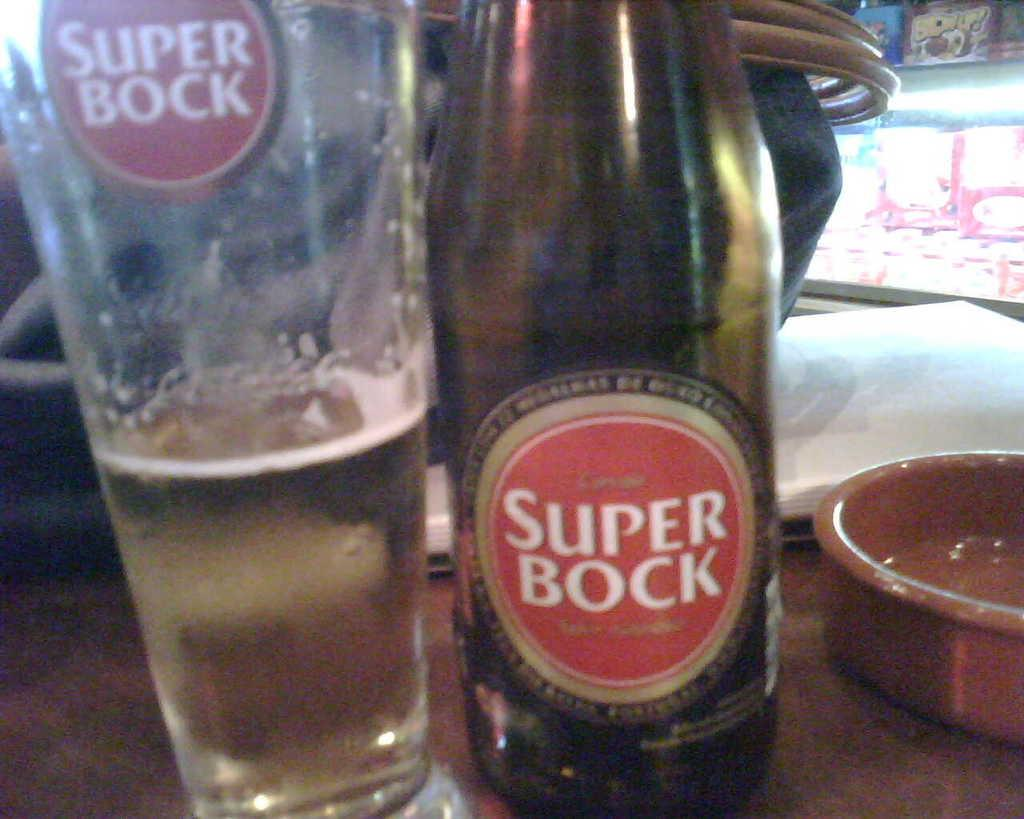<image>
Summarize the visual content of the image. Beer from a Super Bock bottle is poured into a glass. 